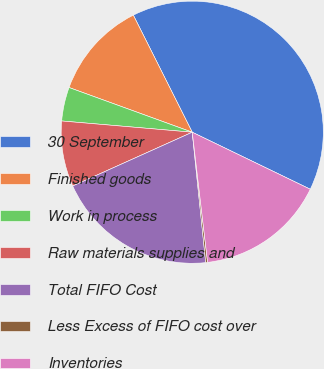Convert chart. <chart><loc_0><loc_0><loc_500><loc_500><pie_chart><fcel>30 September<fcel>Finished goods<fcel>Work in process<fcel>Raw materials supplies and<fcel>Total FIFO Cost<fcel>Less Excess of FIFO cost over<fcel>Inventories<nl><fcel>39.59%<fcel>12.04%<fcel>4.17%<fcel>8.1%<fcel>19.91%<fcel>0.23%<fcel>15.97%<nl></chart> 